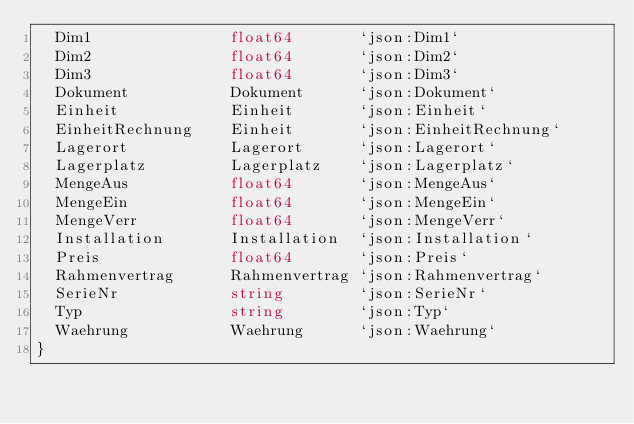Convert code to text. <code><loc_0><loc_0><loc_500><loc_500><_Go_>	Dim1               float64       `json:Dim1`
	Dim2               float64       `json:Dim2`
	Dim3               float64       `json:Dim3`
	Dokument           Dokument      `json:Dokument`
	Einheit            Einheit       `json:Einheit`
	EinheitRechnung    Einheit       `json:EinheitRechnung`
	Lagerort           Lagerort      `json:Lagerort`
	Lagerplatz         Lagerplatz    `json:Lagerplatz`
	MengeAus           float64       `json:MengeAus`
	MengeEin           float64       `json:MengeEin`
	MengeVerr          float64       `json:MengeVerr`
	Installation       Installation  `json:Installation`
	Preis              float64       `json:Preis`
	Rahmenvertrag      Rahmenvertrag `json:Rahmenvertrag`
	SerieNr            string        `json:SerieNr`
	Typ                string        `json:Typ`
	Waehrung           Waehrung      `json:Waehrung`
}
</code> 